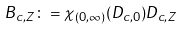Convert formula to latex. <formula><loc_0><loc_0><loc_500><loc_500>B _ { c , Z } \colon = \chi _ { ( 0 , \infty ) } ( D _ { c , 0 } ) D _ { c , Z }</formula> 